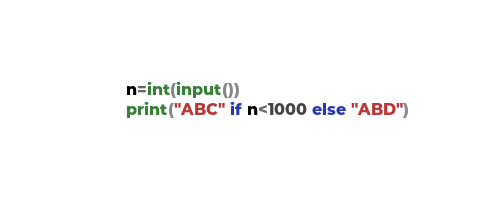<code> <loc_0><loc_0><loc_500><loc_500><_Python_>n=int(input())
print("ABC" if n<1000 else "ABD")</code> 